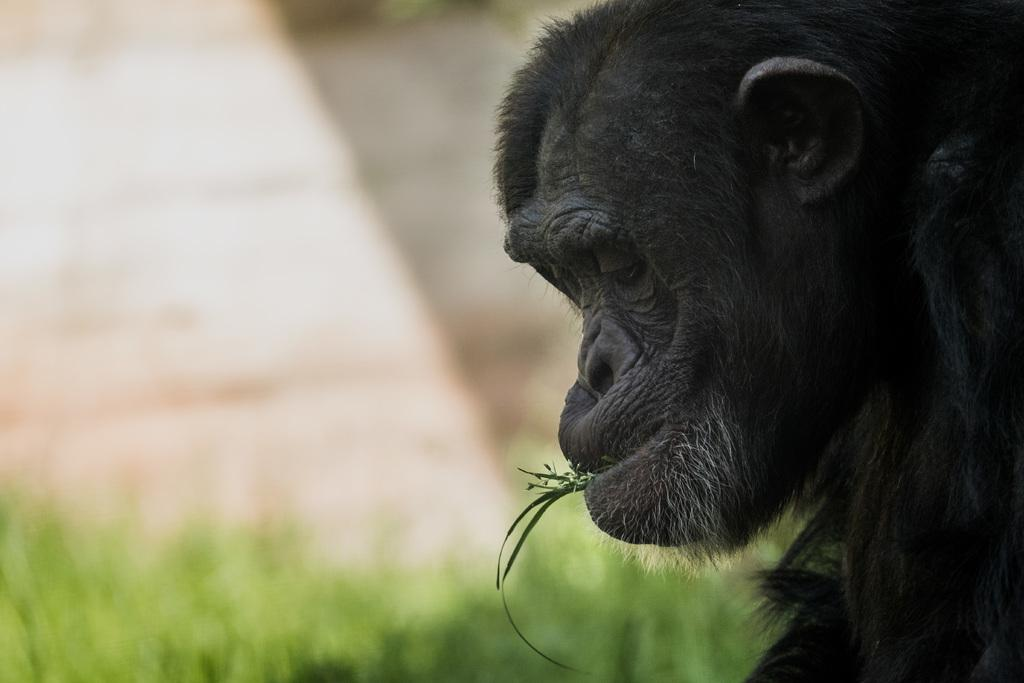What animal is in the picture? There is a monkey in the picture. What color is the monkey? The monkey is black in color. What is the monkey doing in the picture? The monkey has grass in its mouth. What type of surface can be seen in the background of the picture? There is a grass surface visible in the background of the picture, although it is not clearly visible. What type of pancake is the monkey making in the image? There is no pancake present in the image, nor is the monkey making one. 